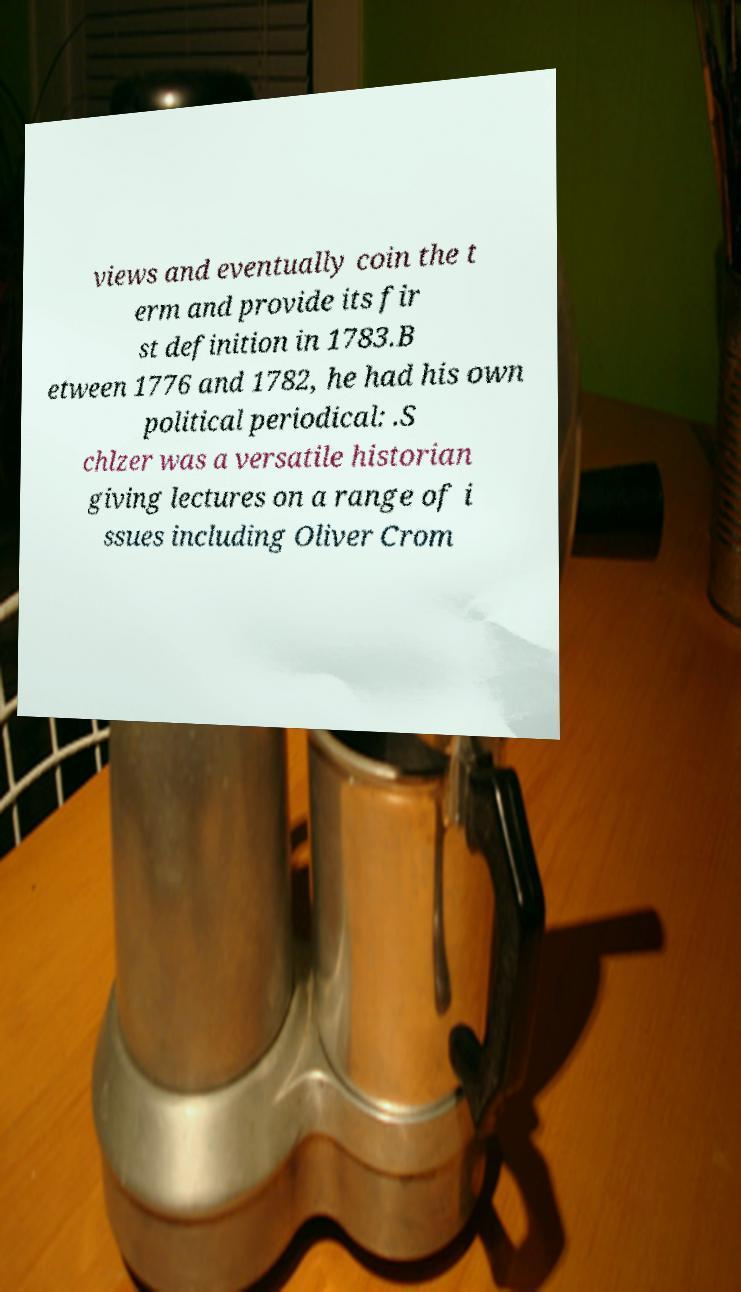Please read and relay the text visible in this image. What does it say? views and eventually coin the t erm and provide its fir st definition in 1783.B etween 1776 and 1782, he had his own political periodical: .S chlzer was a versatile historian giving lectures on a range of i ssues including Oliver Crom 